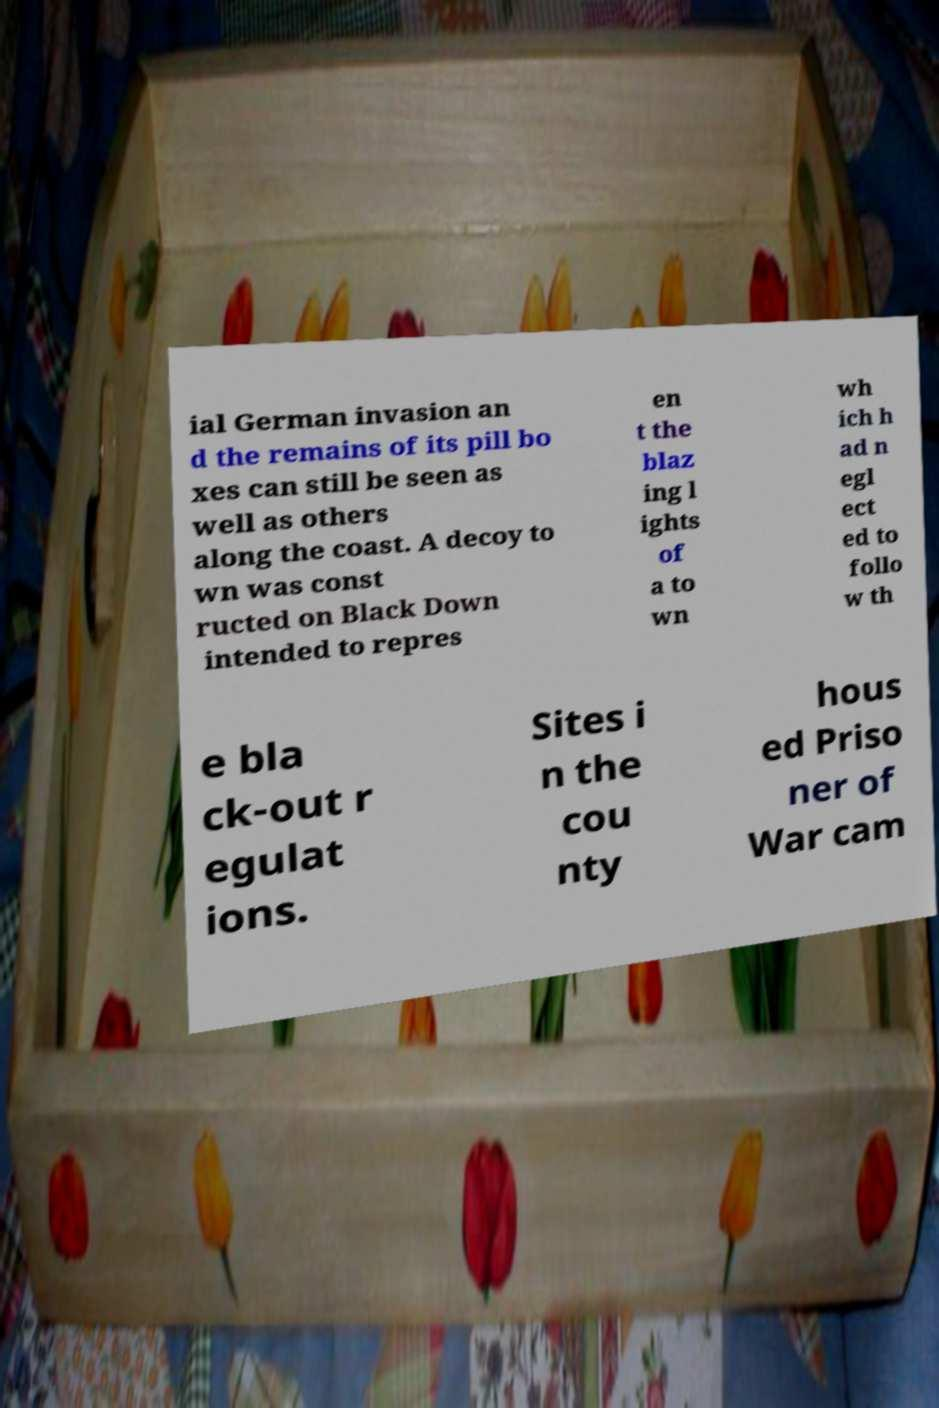Can you accurately transcribe the text from the provided image for me? ial German invasion an d the remains of its pill bo xes can still be seen as well as others along the coast. A decoy to wn was const ructed on Black Down intended to repres en t the blaz ing l ights of a to wn wh ich h ad n egl ect ed to follo w th e bla ck-out r egulat ions. Sites i n the cou nty hous ed Priso ner of War cam 